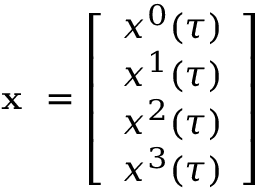Convert formula to latex. <formula><loc_0><loc_0><loc_500><loc_500>x = \left [ \begin{array} { c } { x ^ { 0 } ( \tau ) } \\ { x ^ { 1 } ( \tau ) } \\ { x ^ { 2 } ( \tau ) } \\ { x ^ { 3 } ( \tau ) } \end{array} \right ]</formula> 